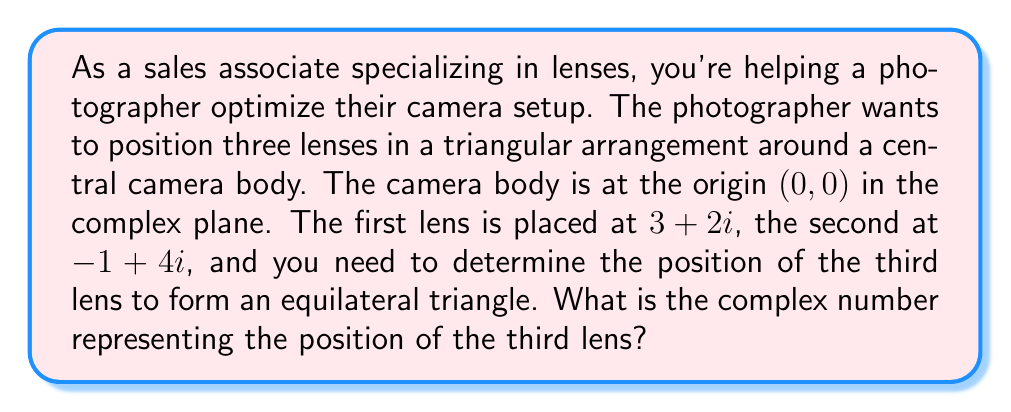Can you answer this question? To solve this problem, we'll use complex numbers and their properties:

1) First, let's identify the given points:
   Camera body: $z_0 = 0 + 0i$
   First lens: $z_1 = 3 + 2i$
   Second lens: $z_2 = -1 + 4i$

2) To form an equilateral triangle, the third point $z_3$ should be such that:
   $|z_1 - z_2| = |z_2 - z_3| = |z_3 - z_1|$

3) We can find $z_3$ by rotating $z_1$ by 120° (2π/3 radians) around $z_2$. The rotation in the complex plane by an angle θ is given by multiplication with $e^{iθ}$. 

4) The rotation formula is:
   $z_3 = z_2 + (z_1 - z_2) \cdot e^{2πi/3}$

5) Let's calculate step by step:
   $z_1 - z_2 = (3+2i) - (-1+4i) = 4-2i$
   $e^{2πi/3} = \cos(2π/3) + i\sin(2π/3) = -1/2 + i\sqrt{3}/2$

6) Now, let's multiply:
   $(4-2i) \cdot (-1/2 + i\sqrt{3}/2) = -2+\sqrt{3}i - i + \sqrt{3}$
                                      $= (-2+\sqrt{3}) + (\sqrt{3}-1)i$

7) Finally, add this to $z_2$:
   $z_3 = (-1+4i) + ((-2+\sqrt{3}) + (\sqrt{3}-1)i)$
        $= (-3+\sqrt{3}) + (3+\sqrt{3})i$

8) Simplify:
   $z_3 = (\sqrt{3}-3) + (3+\sqrt{3})i$
Answer: The position of the third lens is $(\sqrt{3}-3) + (3+\sqrt{3})i$. 